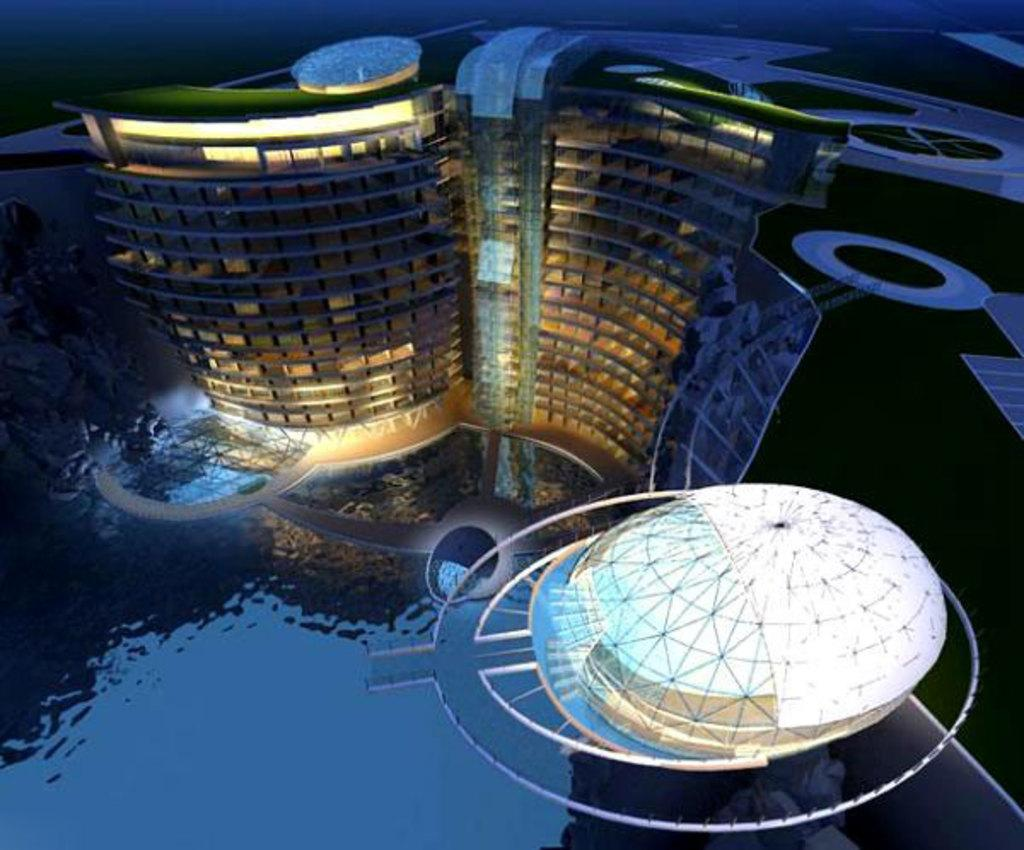What is the primary element visible in the image? There is water in the image. What type of structures can be seen in the image? There are architectural buildings in the image. How much dirt is present in the image? There is no dirt present in the image; it features water and architectural buildings. What type of expansion is occurring in the image? There is no indication of expansion in the image; it primarily shows water and architectural buildings. 